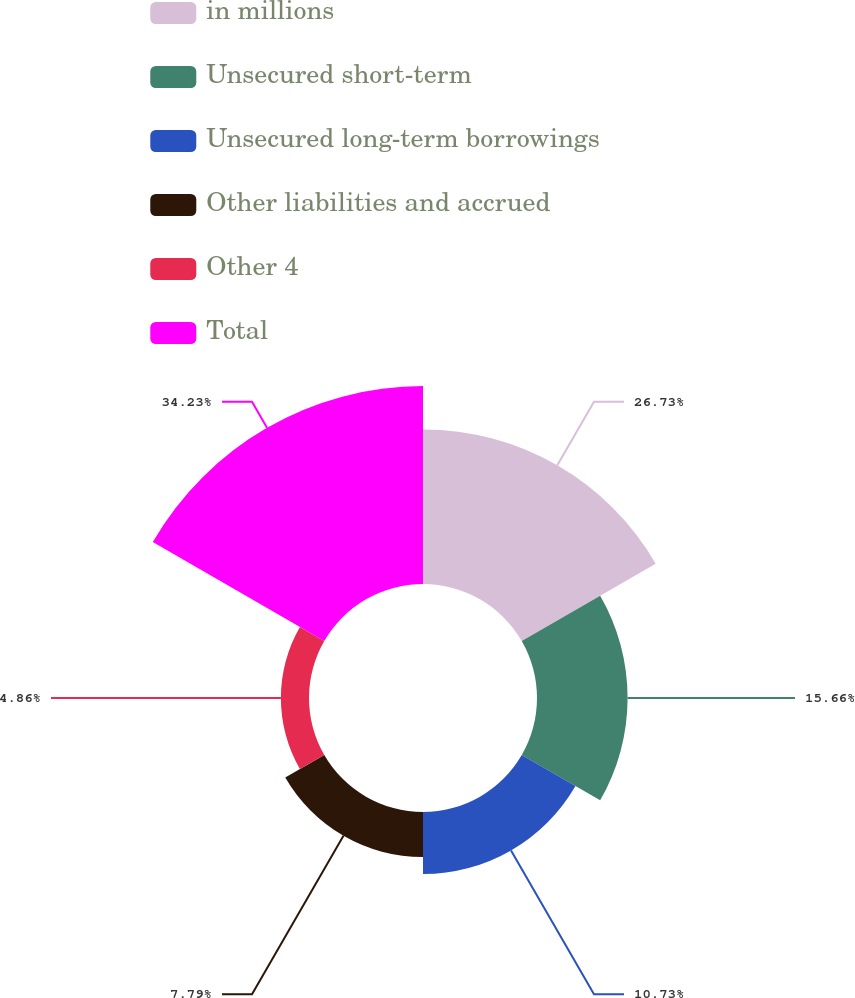Convert chart. <chart><loc_0><loc_0><loc_500><loc_500><pie_chart><fcel>in millions<fcel>Unsecured short-term<fcel>Unsecured long-term borrowings<fcel>Other liabilities and accrued<fcel>Other 4<fcel>Total<nl><fcel>26.73%<fcel>15.66%<fcel>10.73%<fcel>7.79%<fcel>4.86%<fcel>34.23%<nl></chart> 